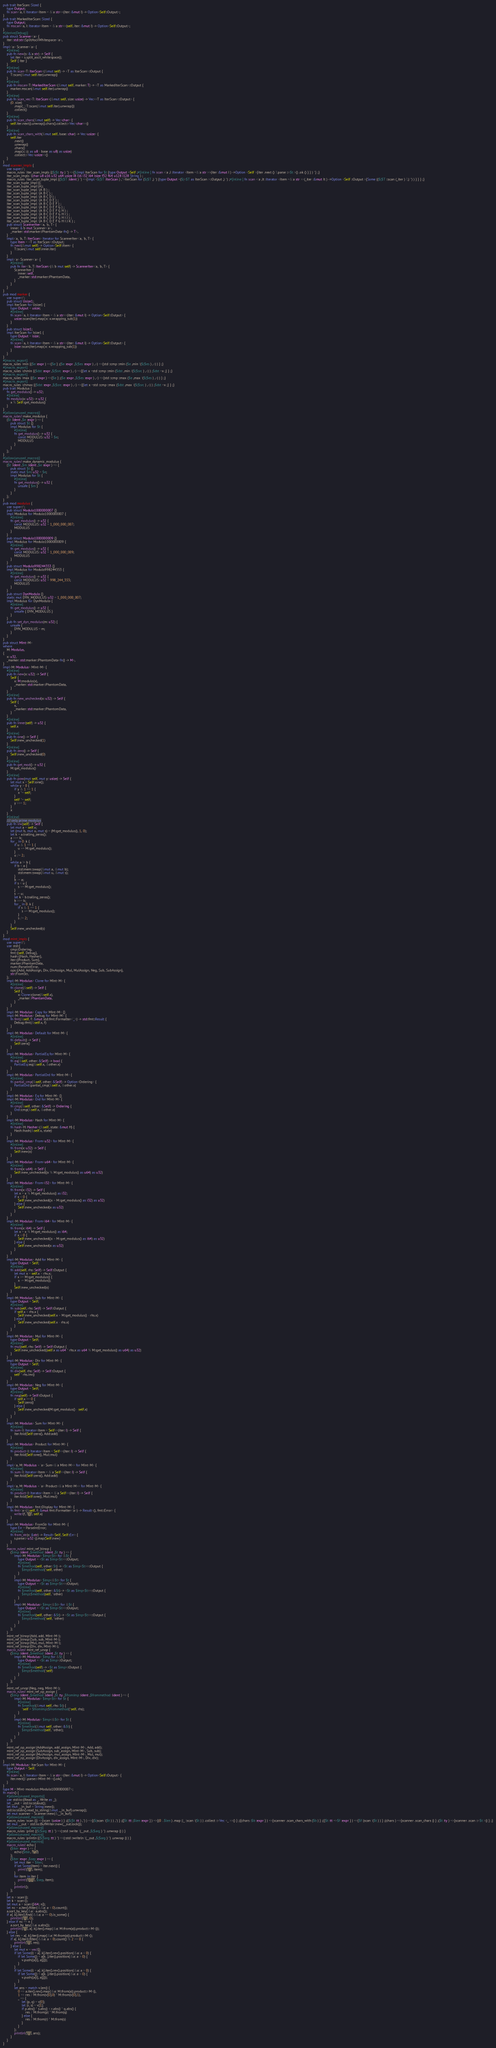<code> <loc_0><loc_0><loc_500><loc_500><_Rust_>pub trait IterScan: Sized {
    type Output;
    fn scan<'a, I: Iterator<Item = &'a str>>(iter: &mut I) -> Option<Self::Output>;
}
pub trait MarkedIterScan: Sized {
    type Output;
    fn mscan<'a, I: Iterator<Item = &'a str>>(self, iter: &mut I) -> Option<Self::Output>;
}
#[derive(Debug)]
pub struct Scanner<'a> {
    iter: std::str::SplitAsciiWhitespace<'a>,
}
impl<'a> Scanner<'a> {
    #[inline]
    pub fn new(s: &'a str) -> Self {
        let iter = s.split_ascii_whitespace();
        Self { iter }
    }
    #[inline]
    pub fn scan<T: IterScan>(&mut self) -> <T as IterScan>::Output {
        T::scan(&mut self.iter).unwrap()
    }
    #[inline]
    pub fn mscan<T: MarkedIterScan>(&mut self, marker: T) -> <T as MarkedIterScan>::Output {
        marker.mscan(&mut self.iter).unwrap()
    }
    #[inline]
    pub fn scan_vec<T: IterScan>(&mut self, size: usize) -> Vec<<T as IterScan>::Output> {
        (0..size)
            .map(|_| T::scan(&mut self.iter).unwrap())
            .collect()
    }
    #[inline]
    pub fn scan_chars(&mut self) -> Vec<char> {
        self.iter.next().unwrap().chars().collect::<Vec<char>>()
    }
    #[inline]
    pub fn scan_chars_with(&mut self, base: char) -> Vec<usize> {
        self.iter
            .next()
            .unwrap()
            .chars()
            .map(|c| (c as u8 - base as u8) as usize)
            .collect::<Vec<usize>>()
    }
}
mod scanner_impls {
    use super::*;
    macro_rules !iter_scan_impls {($($t :ty ) *) =>{$(impl IterScan for $t {type Output =Self ;#[inline ] fn scan <'a ,I :Iterator <Item =&'a str >>(iter :&mut I ) ->Option <Self >{iter .next () ?.parse ::<$t >() .ok () } } ) *} ;}
    iter_scan_impls !(char u8 u16 u32 u64 usize i8 i16 i32 i64 isize f32 f64 u128 i128 String ) ;
    macro_rules !iter_scan_tuple_impl {($($T :ident ) *) =>{impl <$($T :IterScan ) ,*>IterScan for ($($T ,) *) {type Output =($(<$T as IterScan >::Output ,) *) ;#[inline ] fn scan <'a ,It :Iterator <Item =&'a str >>(_iter :&mut It ) ->Option <Self ::Output >{Some (($($T ::scan (_iter ) ?,) *) ) } } } ;}
    iter_scan_tuple_impl!();
    iter_scan_tuple_impl!(A);
    iter_scan_tuple_impl !(A B ) ;
    iter_scan_tuple_impl !(A B C ) ;
    iter_scan_tuple_impl !(A B C D ) ;
    iter_scan_tuple_impl !(A B C D E ) ;
    iter_scan_tuple_impl !(A B C D E F ) ;
    iter_scan_tuple_impl !(A B C D E F G ) ;
    iter_scan_tuple_impl !(A B C D E F G H ) ;
    iter_scan_tuple_impl !(A B C D E F G H I ) ;
    iter_scan_tuple_impl !(A B C D E F G H I J ) ;
    iter_scan_tuple_impl !(A B C D E F G H I J K ) ;
    pub struct ScannerIter<'a, 'b, T> {
        inner: &'b mut Scanner<'a>,
        _marker: std::marker::PhantomData<fn() -> T>,
    }
    impl<'a, 'b, T: IterScan> Iterator for ScannerIter<'a, 'b, T> {
        type Item = <T as IterScan>::Output;
        fn next(&mut self) -> Option<Self::Item> {
            T::scan(&mut self.inner.iter)
        }
    }
    impl<'a> Scanner<'a> {
        #[inline]
        pub fn iter<'b, T: IterScan>(&'b mut self) -> ScannerIter<'a, 'b, T> {
            ScannerIter {
                inner: self,
                _marker: std::marker::PhantomData,
            }
        }
    }
}
pub mod marker {
    use super::*;
    pub struct Usize1;
    impl IterScan for Usize1 {
        type Output = usize;
        #[inline]
        fn scan<'a, I: Iterator<Item = &'a str>>(iter: &mut I) -> Option<Self::Output> {
            usize::scan(iter).map(|x| x.wrapping_sub(1))
        }
    }
    pub struct Isize1;
    impl IterScan for Isize1 {
        type Output = isize;
        #[inline]
        fn scan<'a, I: Iterator<Item = &'a str>>(iter: &mut I) -> Option<Self::Output> {
            isize::scan(iter).map(|x| x.wrapping_sub(1))
        }
    }
}
#[macro_export]
macro_rules !min {($e :expr ) =>{$e } ;($e :expr ,$($es :expr ) ,+) =>{std ::cmp ::min ($e ,min !($($es ) ,+) ) } ;}
#[macro_export]
macro_rules !chmin {($dst :expr ,$($src :expr ) ,+) =>{{let x =std ::cmp ::min ($dst ,min !($($src ) ,+) ) ;$dst =x ;} } ;}
#[macro_export]
macro_rules !max {($e :expr ) =>{$e } ;($e :expr ,$($es :expr ) ,+) =>{std ::cmp ::max ($e ,max !($($es ) ,+) ) } ;}
#[macro_export]
macro_rules !chmax {($dst :expr ,$($src :expr ) ,+) =>{{let x =std ::cmp ::max ($dst ,max !($($src ) ,+) ) ;$dst =x ;} } ;}
pub trait Modulus {
    fn get_modulus() -> u32;
    #[inline]
    fn modulo(x: u32) -> u32 {
        x % Self::get_modulus()
    }
}
#[allow(unused_macros)]
macro_rules! make_modulus {
    ($t :ident ,$e :expr ) => {
        pub struct $t {}
        impl Modulus for $t {
            #[inline]
            fn get_modulus() -> u32 {
                const MODULUS: u32 = $e;
                MODULUS
            }
        }
    };
}
#[allow(unused_macros)]
macro_rules! make_dynamic_modulus {
    ($t :ident ,$m :ident ,$e :expr ) => {
        pub struct $t {}
        static mut $m: u32 = $e;
        impl Modulus for $t {
            #[inline]
            fn get_modulus() -> u32 {
                unsafe { $m }
            }
        }
    };
}
pub mod modulus {
    use super::*;
    pub struct Modulo1000000007 {}
    impl Modulus for Modulo1000000007 {
        #[inline]
        fn get_modulus() -> u32 {
            const MODULUS: u32 = 1_000_000_007;
            MODULUS
        }
    }
    pub struct Modulo1000000009 {}
    impl Modulus for Modulo1000000009 {
        #[inline]
        fn get_modulus() -> u32 {
            const MODULUS: u32 = 1_000_000_009;
            MODULUS
        }
    }
    pub struct Modulo998244353 {}
    impl Modulus for Modulo998244353 {
        #[inline]
        fn get_modulus() -> u32 {
            const MODULUS: u32 = 998_244_353;
            MODULUS
        }
    }
    pub struct DynModulo {}
    static mut DYN_MODULUS: u32 = 1_000_000_007;
    impl Modulus for DynModulo {
        #[inline]
        fn get_modulus() -> u32 {
            unsafe { DYN_MODULUS }
        }
    }
    pub fn set_dyn_modulus(m: u32) {
        unsafe {
            DYN_MODULUS = m;
        }
    }
}
pub struct MInt<M>
where
    M: Modulus,
{
    x: u32,
    _marker: std::marker::PhantomData<fn() -> M>,
}
impl<M: Modulus> MInt<M> {
    #[inline]
    pub fn new(x: u32) -> Self {
        Self {
            x: M::modulo(x),
            _marker: std::marker::PhantomData,
        }
    }
    #[inline]
    pub fn new_unchecked(x: u32) -> Self {
        Self {
            x,
            _marker: std::marker::PhantomData,
        }
    }
    #[inline]
    pub fn inner(self) -> u32 {
        self.x
    }
    #[inline]
    pub fn one() -> Self {
        Self::new_unchecked(1)
    }
    #[inline]
    pub fn zero() -> Self {
        Self::new_unchecked(0)
    }
    #[inline]
    pub fn get_mod() -> u32 {
        M::get_modulus()
    }
    #[inline]
    pub fn pow(mut self, mut y: usize) -> Self {
        let mut x = Self::one();
        while y > 0 {
            if y & 1 == 1 {
                x *= self;
            }
            self *= self;
            y >>= 1;
        }
        x
    }
    #[inline]
    /// only prime modulus
    pub fn inv(self) -> Self {
        let mut a = self.x;
        let (mut b, mut u, mut s) = (M::get_modulus(), 1, 0);
        let k = a.trailing_zeros();
        a >>= k;
        for _ in 0..k {
            if u & 1 == 1 {
                u += M::get_modulus();
            }
            u /= 2;
        }
        while a != b {
            if b < a {
                std::mem::swap(&mut a, &mut b);
                std::mem::swap(&mut u, &mut s);
            }
            b -= a;
            if s < u {
                s += M::get_modulus();
            }
            s -= u;
            let k = b.trailing_zeros();
            b >>= k;
            for _ in 0..k {
                if s & 1 == 1 {
                    s += M::get_modulus();
                }
                s /= 2;
            }
        }
        Self::new_unchecked(s)
    }
}
mod mint_impls {
    use super::*;
    use std::{
        cmp::Ordering,
        fmt::{self, Debug},
        hash::{Hash, Hasher},
        iter::{Product, Sum},
        marker::PhantomData,
        num::ParseIntError,
        ops::{Add, AddAssign, Div, DivAssign, Mul, MulAssign, Neg, Sub, SubAssign},
        str::FromStr,
    };
    impl<M: Modulus> Clone for MInt<M> {
        #[inline]
        fn clone(&self) -> Self {
            Self {
                x: Clone::clone(&self.x),
                _marker: PhantomData,
            }
        }
    }
    impl<M: Modulus> Copy for MInt<M> {}
    impl<M: Modulus> Debug for MInt<M> {
        fn fmt(&self, f: &mut std::fmt::Formatter<'_>) -> std::fmt::Result {
            Debug::fmt(&self.x, f)
        }
    }
    impl<M: Modulus> Default for MInt<M> {
        #[inline]
        fn default() -> Self {
            Self::zero()
        }
    }
    impl<M: Modulus> PartialEq for MInt<M> {
        #[inline]
        fn eq(&self, other: &Self) -> bool {
            PartialEq::eq(&self.x, &other.x)
        }
    }
    impl<M: Modulus> PartialOrd for MInt<M> {
        #[inline]
        fn partial_cmp(&self, other: &Self) -> Option<Ordering> {
            PartialOrd::partial_cmp(&self.x, &other.x)
        }
    }
    impl<M: Modulus> Eq for MInt<M> {}
    impl<M: Modulus> Ord for MInt<M> {
        #[inline]
        fn cmp(&self, other: &Self) -> Ordering {
            Ord::cmp(&self.x, &other.x)
        }
    }
    impl<M: Modulus> Hash for MInt<M> {
        #[inline]
        fn hash<H: Hasher>(&self, state: &mut H) {
            Hash::hash(&self.x, state)
        }
    }
    impl<M: Modulus> From<u32> for MInt<M> {
        #[inline]
        fn from(x: u32) -> Self {
            Self::new(x)
        }
    }
    impl<M: Modulus> From<u64> for MInt<M> {
        #[inline]
        fn from(x: u64) -> Self {
            Self::new_unchecked((x % M::get_modulus() as u64) as u32)
        }
    }
    impl<M: Modulus> From<i32> for MInt<M> {
        #[inline]
        fn from(x: i32) -> Self {
            let x = x % M::get_modulus() as i32;
            if x < 0 {
                Self::new_unchecked((x + M::get_modulus() as i32) as u32)
            } else {
                Self::new_unchecked(x as u32)
            }
        }
    }
    impl<M: Modulus> From<i64> for MInt<M> {
        #[inline]
        fn from(x: i64) -> Self {
            let x = x % M::get_modulus() as i64;
            if x < 0 {
                Self::new_unchecked((x + M::get_modulus() as i64) as u32)
            } else {
                Self::new_unchecked(x as u32)
            }
        }
    }
    impl<M: Modulus> Add for MInt<M> {
        type Output = Self;
        #[inline]
        fn add(self, rhs: Self) -> Self::Output {
            let mut x = self.x + rhs.x;
            if x >= M::get_modulus() {
                x -= M::get_modulus();
            }
            Self::new_unchecked(x)
        }
    }
    impl<M: Modulus> Sub for MInt<M> {
        type Output = Self;
        #[inline]
        fn sub(self, rhs: Self) -> Self::Output {
            if self.x < rhs.x {
                Self::new_unchecked(self.x + M::get_modulus() - rhs.x)
            } else {
                Self::new_unchecked(self.x - rhs.x)
            }
        }
    }
    impl<M: Modulus> Mul for MInt<M> {
        type Output = Self;
        #[inline]
        fn mul(self, rhs: Self) -> Self::Output {
            Self::new_unchecked((self.x as u64 * rhs.x as u64 % M::get_modulus() as u64) as u32)
        }
    }
    impl<M: Modulus> Div for MInt<M> {
        type Output = Self;
        #[inline]
        fn div(self, rhs: Self) -> Self::Output {
            self * rhs.inv()
        }
    }
    impl<M: Modulus> Neg for MInt<M> {
        type Output = Self;
        #[inline]
        fn neg(self) -> Self::Output {
            if self.x == 0 {
                Self::zero()
            } else {
                Self::new_unchecked(M::get_modulus() - self.x)
            }
        }
    }
    impl<M: Modulus> Sum for MInt<M> {
        #[inline]
        fn sum<I: Iterator<Item = Self>>(iter: I) -> Self {
            iter.fold(Self::zero(), Add::add)
        }
    }
    impl<M: Modulus> Product for MInt<M> {
        #[inline]
        fn product<I: Iterator<Item = Self>>(iter: I) -> Self {
            iter.fold(Self::one(), Mul::mul)
        }
    }
    impl<'a, M: Modulus + 'a> Sum<&'a MInt<M>> for MInt<M> {
        #[inline]
        fn sum<I: Iterator<Item = &'a Self>>(iter: I) -> Self {
            iter.fold(Self::zero(), Add::add)
        }
    }
    impl<'a, M: Modulus + 'a> Product<&'a MInt<M>> for MInt<M> {
        #[inline]
        fn product<I: Iterator<Item = &'a Self>>(iter: I) -> Self {
            iter.fold(Self::one(), Mul::mul)
        }
    }
    impl<M: Modulus> fmt::Display for MInt<M> {
        fn fmt<'a>(&self, f: &mut fmt::Formatter<'a>) -> Result<(), fmt::Error> {
            write!(f, "{}", self.x)
        }
    }
    impl<M: Modulus> FromStr for MInt<M> {
        type Err = ParseIntError;
        #[inline]
        fn from_str(s: &str) -> Result<Self, Self::Err> {
            s.parse::<u32>().map(Self::new)
        }
    }
    macro_rules! mint_ref_binop {
        ($imp :ident ,$method :ident ,$t :ty ) => {
            impl<M: Modulus> $imp<$t> for &$t {
                type Output = <$t as $imp<$t>>::Output;
                #[inline]
                fn $method(self, other: $t) -> <$t as $imp<$t>>::Output {
                    $imp::$method(*self, other)
                }
            }
            impl<M: Modulus> $imp<&$t> for $t {
                type Output = <$t as $imp<$t>>::Output;
                #[inline]
                fn $method(self, other: &$t) -> <$t as $imp<$t>>::Output {
                    $imp::$method(self, *other)
                }
            }
            impl<M: Modulus> $imp<&$t> for &$t {
                type Output = <$t as $imp<$t>>::Output;
                #[inline]
                fn $method(self, other: &$t) -> <$t as $imp<$t>>::Output {
                    $imp::$method(*self, *other)
                }
            }
        };
    }
    mint_ref_binop!(Add, add, MInt<M>);
    mint_ref_binop!(Sub, sub, MInt<M>);
    mint_ref_binop!(Mul, mul, MInt<M>);
    mint_ref_binop!(Div, div, MInt<M>);
    macro_rules! mint_ref_unop {
        ($imp :ident ,$method :ident ,$t :ty ) => {
            impl<M: Modulus> $imp for &$t {
                type Output = <$t as $imp>::Output;
                #[inline]
                fn $method(self) -> <$t as $imp>::Output {
                    $imp::$method(*self)
                }
            }
        };
    }
    mint_ref_unop!(Neg, neg, MInt<M>);
    macro_rules! mint_ref_op_assign {
        ($imp :ident ,$method :ident ,$t :ty ,$fromimp :ident ,$frommethod :ident ) => {
            impl<M: Modulus> $imp<$t> for $t {
                #[inline]
                fn $method(&mut self, rhs: $t) {
                    *self = $fromimp::$frommethod(*self, rhs);
                }
            }
            impl<M: Modulus> $imp<&$t> for $t {
                #[inline]
                fn $method(&mut self, other: &$t) {
                    $imp::$method(self, *other);
                }
            }
        };
    }
    mint_ref_op_assign!(AddAssign, add_assign, MInt<M>, Add, add);
    mint_ref_op_assign!(SubAssign, sub_assign, MInt<M>, Sub, sub);
    mint_ref_op_assign!(MulAssign, mul_assign, MInt<M>, Mul, mul);
    mint_ref_op_assign!(DivAssign, div_assign, MInt<M>, Div, div);
}
impl<M: Modulus> IterScan for MInt<M> {
    type Output = Self;
    #[inline]
    fn scan<'a, I: Iterator<Item = &'a str>>(iter: &mut I) -> Option<Self::Output> {
        iter.next()?.parse::<MInt<M>>().ok()
    }
}
type M = MInt<modulus::Modulo1000000007>;
fn main() {
    #[allow(unused_imports)]
    use std::io::{Read as _, Write as _};
    let __out = std::io::stdout();
    let mut __in_buf = String::new();
    std::io::stdin().read_to_string(&mut __in_buf).unwrap();
    let mut scanner = Scanner::new(&__in_buf);
    #[allow(unused_macros)]
    macro_rules !scan {() =>{scan !(usize ) } ;(($($t :tt ) ,*) ) =>{($(scan !($t ) ) ,*) } ;([$t :tt ;$len :expr ] ) =>{(0 ..$len ) .map (|_ |scan !($t ) ) .collect ::<Vec <_ >>() } ;({chars :$b :expr } ) =>{scanner .scan_chars_with ($b ) } ;({$t :tt =>$f :expr } ) =>{$f (scan !($t ) ) } ;(chars ) =>{scanner .scan_chars () } ;($t :ty ) =>{scanner .scan ::<$t >() } ;}
    let mut __out = std::io::BufWriter::new(__out.lock());
    #[allow(unused_macros)]
    macro_rules !print {($($arg :tt ) *) =>(::std ::write !(__out ,$($arg ) *) .unwrap () ) }
    #[allow(unused_macros)]
    macro_rules !println {($($arg :tt ) *) =>(::std ::writeln !(__out ,$($arg ) *) .unwrap () ) }
    #[allow(unused_macros)]
    macro_rules! echo {
        ($iter :expr ) => {
            echo!($iter, "\n")
        };
        ($iter :expr ,$sep :expr ) => {
            let mut iter = $iter;
            if let Some(item) = iter.next() {
                print!("{}", item);
            }
            for item in iter {
                print!("{}{}", $sep, item);
            }
            println!();
        };
    }
    let n = scan!();
    let k = scan!();
    let mut a = scan!([i64; n]);
    let nc = a.iter().filter(|&&a| a < 0).count();
    a.sort_by_key(|&a| -a.abs());
    if a[..k].iter().find(|&&a| a == 0).is_some() {
        println!("{}", 0);
    } else if nc == n {
        a.sort_by_key(|&a| a.abs());
        println!("{}", a[..k].iter().map(|&a| M::from(a)).product::<M>());
    } else {
        let res = a[..k].iter().map(|&a| M::from(a)).product::<M>();
        if a[..k].iter().filter(|&&a| a < 0).count() % 2 == 0 {
            println!("{}", res);
        } else {
            let mut v = vec![];
            if let Some(i) = a[..k].iter().rev().position(|&a| a < 0) {
                if let Some(j) = a[k..].iter().position(|&a| a > 0) {
                    v.push((a[i], a[j]));
                }
            }
            if let Some(i) = a[..k].iter().rev().position(|&a| a > 0) {
                if let Some(j) = a[k..].iter().position(|&a| a < 0) {
                    v.push((a[i], a[j]));
                }
            }
            let ans = match v.len() {
                0 => a.iter().rev().map(|&a| M::from(a)).product::<M>(),
                1 => res / M::from(v[0].0) * M::from(v[0].1),
                _ => {
                    let (p, q) = v[0];
                    let (r, s) = v[1];
                    if p.abs() * s.abs() < r.abs() * q.abs() {
                        res / M::from(p) * M::from(q)
                    } else {
                        res / M::from(r) * M::from(s)
                    }
                }
            };
            println!("{}", ans);
        }
    }
}</code> 